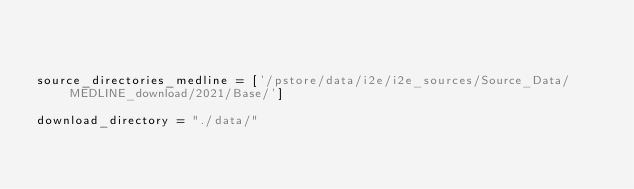Convert code to text. <code><loc_0><loc_0><loc_500><loc_500><_Python_>


source_directories_medline = ['/pstore/data/i2e/i2e_sources/Source_Data/MEDLINE_download/2021/Base/']

download_directory = "./data/"
</code> 